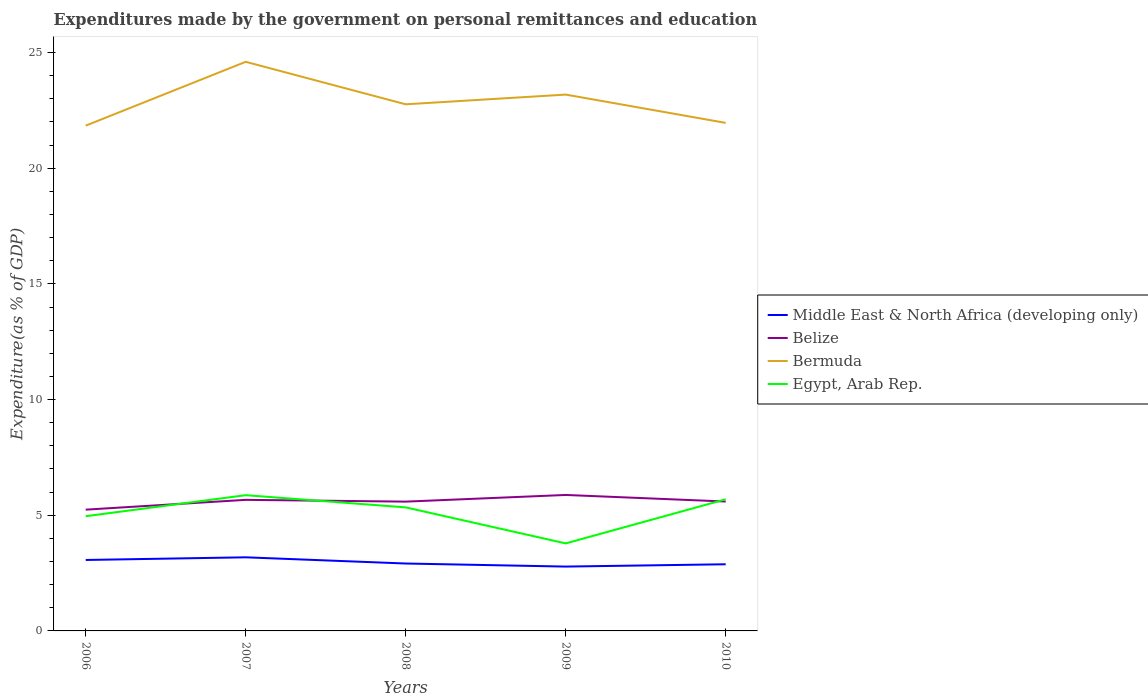Is the number of lines equal to the number of legend labels?
Make the answer very short. Yes. Across all years, what is the maximum expenditures made by the government on personal remittances and education in Bermuda?
Give a very brief answer. 21.84. What is the total expenditures made by the government on personal remittances and education in Middle East & North Africa (developing only) in the graph?
Your answer should be very brief. -0.11. What is the difference between the highest and the second highest expenditures made by the government on personal remittances and education in Egypt, Arab Rep.?
Your answer should be very brief. 2.08. Is the expenditures made by the government on personal remittances and education in Middle East & North Africa (developing only) strictly greater than the expenditures made by the government on personal remittances and education in Egypt, Arab Rep. over the years?
Keep it short and to the point. Yes. How many years are there in the graph?
Your answer should be compact. 5. What is the difference between two consecutive major ticks on the Y-axis?
Offer a terse response. 5. Does the graph contain grids?
Ensure brevity in your answer.  No. Where does the legend appear in the graph?
Your answer should be compact. Center right. How many legend labels are there?
Ensure brevity in your answer.  4. What is the title of the graph?
Your response must be concise. Expenditures made by the government on personal remittances and education. What is the label or title of the X-axis?
Your response must be concise. Years. What is the label or title of the Y-axis?
Your answer should be very brief. Expenditure(as % of GDP). What is the Expenditure(as % of GDP) in Middle East & North Africa (developing only) in 2006?
Offer a terse response. 3.07. What is the Expenditure(as % of GDP) of Belize in 2006?
Provide a succinct answer. 5.24. What is the Expenditure(as % of GDP) in Bermuda in 2006?
Give a very brief answer. 21.84. What is the Expenditure(as % of GDP) of Egypt, Arab Rep. in 2006?
Your response must be concise. 4.96. What is the Expenditure(as % of GDP) in Middle East & North Africa (developing only) in 2007?
Your response must be concise. 3.18. What is the Expenditure(as % of GDP) in Belize in 2007?
Your answer should be compact. 5.67. What is the Expenditure(as % of GDP) of Bermuda in 2007?
Make the answer very short. 24.6. What is the Expenditure(as % of GDP) of Egypt, Arab Rep. in 2007?
Provide a short and direct response. 5.87. What is the Expenditure(as % of GDP) in Middle East & North Africa (developing only) in 2008?
Give a very brief answer. 2.91. What is the Expenditure(as % of GDP) in Belize in 2008?
Provide a succinct answer. 5.59. What is the Expenditure(as % of GDP) of Bermuda in 2008?
Your response must be concise. 22.76. What is the Expenditure(as % of GDP) in Egypt, Arab Rep. in 2008?
Your response must be concise. 5.34. What is the Expenditure(as % of GDP) of Middle East & North Africa (developing only) in 2009?
Provide a short and direct response. 2.78. What is the Expenditure(as % of GDP) in Belize in 2009?
Your answer should be very brief. 5.88. What is the Expenditure(as % of GDP) of Bermuda in 2009?
Provide a succinct answer. 23.18. What is the Expenditure(as % of GDP) of Egypt, Arab Rep. in 2009?
Provide a succinct answer. 3.78. What is the Expenditure(as % of GDP) of Middle East & North Africa (developing only) in 2010?
Your answer should be very brief. 2.88. What is the Expenditure(as % of GDP) of Belize in 2010?
Provide a succinct answer. 5.59. What is the Expenditure(as % of GDP) in Bermuda in 2010?
Your answer should be compact. 21.96. What is the Expenditure(as % of GDP) of Egypt, Arab Rep. in 2010?
Offer a very short reply. 5.69. Across all years, what is the maximum Expenditure(as % of GDP) of Middle East & North Africa (developing only)?
Give a very brief answer. 3.18. Across all years, what is the maximum Expenditure(as % of GDP) of Belize?
Give a very brief answer. 5.88. Across all years, what is the maximum Expenditure(as % of GDP) of Bermuda?
Your answer should be very brief. 24.6. Across all years, what is the maximum Expenditure(as % of GDP) in Egypt, Arab Rep.?
Your answer should be compact. 5.87. Across all years, what is the minimum Expenditure(as % of GDP) in Middle East & North Africa (developing only)?
Ensure brevity in your answer.  2.78. Across all years, what is the minimum Expenditure(as % of GDP) in Belize?
Your answer should be compact. 5.24. Across all years, what is the minimum Expenditure(as % of GDP) of Bermuda?
Your response must be concise. 21.84. Across all years, what is the minimum Expenditure(as % of GDP) in Egypt, Arab Rep.?
Make the answer very short. 3.78. What is the total Expenditure(as % of GDP) in Middle East & North Africa (developing only) in the graph?
Your answer should be very brief. 14.83. What is the total Expenditure(as % of GDP) of Belize in the graph?
Make the answer very short. 27.97. What is the total Expenditure(as % of GDP) of Bermuda in the graph?
Your answer should be very brief. 114.34. What is the total Expenditure(as % of GDP) in Egypt, Arab Rep. in the graph?
Provide a succinct answer. 25.64. What is the difference between the Expenditure(as % of GDP) of Middle East & North Africa (developing only) in 2006 and that in 2007?
Provide a short and direct response. -0.11. What is the difference between the Expenditure(as % of GDP) in Belize in 2006 and that in 2007?
Your answer should be very brief. -0.42. What is the difference between the Expenditure(as % of GDP) in Bermuda in 2006 and that in 2007?
Your response must be concise. -2.76. What is the difference between the Expenditure(as % of GDP) in Egypt, Arab Rep. in 2006 and that in 2007?
Your response must be concise. -0.91. What is the difference between the Expenditure(as % of GDP) in Middle East & North Africa (developing only) in 2006 and that in 2008?
Give a very brief answer. 0.15. What is the difference between the Expenditure(as % of GDP) in Belize in 2006 and that in 2008?
Keep it short and to the point. -0.35. What is the difference between the Expenditure(as % of GDP) in Bermuda in 2006 and that in 2008?
Give a very brief answer. -0.92. What is the difference between the Expenditure(as % of GDP) of Egypt, Arab Rep. in 2006 and that in 2008?
Ensure brevity in your answer.  -0.38. What is the difference between the Expenditure(as % of GDP) of Middle East & North Africa (developing only) in 2006 and that in 2009?
Ensure brevity in your answer.  0.29. What is the difference between the Expenditure(as % of GDP) of Belize in 2006 and that in 2009?
Provide a short and direct response. -0.64. What is the difference between the Expenditure(as % of GDP) of Bermuda in 2006 and that in 2009?
Keep it short and to the point. -1.34. What is the difference between the Expenditure(as % of GDP) in Egypt, Arab Rep. in 2006 and that in 2009?
Offer a very short reply. 1.18. What is the difference between the Expenditure(as % of GDP) in Middle East & North Africa (developing only) in 2006 and that in 2010?
Provide a short and direct response. 0.19. What is the difference between the Expenditure(as % of GDP) of Belize in 2006 and that in 2010?
Your answer should be very brief. -0.35. What is the difference between the Expenditure(as % of GDP) of Bermuda in 2006 and that in 2010?
Your answer should be compact. -0.12. What is the difference between the Expenditure(as % of GDP) in Egypt, Arab Rep. in 2006 and that in 2010?
Offer a terse response. -0.73. What is the difference between the Expenditure(as % of GDP) in Middle East & North Africa (developing only) in 2007 and that in 2008?
Offer a terse response. 0.27. What is the difference between the Expenditure(as % of GDP) of Belize in 2007 and that in 2008?
Your answer should be compact. 0.08. What is the difference between the Expenditure(as % of GDP) in Bermuda in 2007 and that in 2008?
Offer a very short reply. 1.84. What is the difference between the Expenditure(as % of GDP) in Egypt, Arab Rep. in 2007 and that in 2008?
Your answer should be very brief. 0.53. What is the difference between the Expenditure(as % of GDP) in Middle East & North Africa (developing only) in 2007 and that in 2009?
Your answer should be compact. 0.4. What is the difference between the Expenditure(as % of GDP) of Belize in 2007 and that in 2009?
Keep it short and to the point. -0.21. What is the difference between the Expenditure(as % of GDP) in Bermuda in 2007 and that in 2009?
Provide a short and direct response. 1.42. What is the difference between the Expenditure(as % of GDP) of Egypt, Arab Rep. in 2007 and that in 2009?
Keep it short and to the point. 2.08. What is the difference between the Expenditure(as % of GDP) of Middle East & North Africa (developing only) in 2007 and that in 2010?
Give a very brief answer. 0.3. What is the difference between the Expenditure(as % of GDP) of Belize in 2007 and that in 2010?
Provide a short and direct response. 0.07. What is the difference between the Expenditure(as % of GDP) in Bermuda in 2007 and that in 2010?
Provide a short and direct response. 2.64. What is the difference between the Expenditure(as % of GDP) in Egypt, Arab Rep. in 2007 and that in 2010?
Make the answer very short. 0.18. What is the difference between the Expenditure(as % of GDP) in Middle East & North Africa (developing only) in 2008 and that in 2009?
Provide a succinct answer. 0.13. What is the difference between the Expenditure(as % of GDP) of Belize in 2008 and that in 2009?
Make the answer very short. -0.29. What is the difference between the Expenditure(as % of GDP) of Bermuda in 2008 and that in 2009?
Your answer should be compact. -0.42. What is the difference between the Expenditure(as % of GDP) of Egypt, Arab Rep. in 2008 and that in 2009?
Keep it short and to the point. 1.56. What is the difference between the Expenditure(as % of GDP) in Middle East & North Africa (developing only) in 2008 and that in 2010?
Keep it short and to the point. 0.03. What is the difference between the Expenditure(as % of GDP) of Belize in 2008 and that in 2010?
Provide a short and direct response. -0. What is the difference between the Expenditure(as % of GDP) in Bermuda in 2008 and that in 2010?
Your answer should be very brief. 0.8. What is the difference between the Expenditure(as % of GDP) of Egypt, Arab Rep. in 2008 and that in 2010?
Offer a very short reply. -0.35. What is the difference between the Expenditure(as % of GDP) in Middle East & North Africa (developing only) in 2009 and that in 2010?
Your answer should be compact. -0.1. What is the difference between the Expenditure(as % of GDP) of Belize in 2009 and that in 2010?
Keep it short and to the point. 0.28. What is the difference between the Expenditure(as % of GDP) of Bermuda in 2009 and that in 2010?
Your response must be concise. 1.22. What is the difference between the Expenditure(as % of GDP) in Egypt, Arab Rep. in 2009 and that in 2010?
Provide a succinct answer. -1.91. What is the difference between the Expenditure(as % of GDP) of Middle East & North Africa (developing only) in 2006 and the Expenditure(as % of GDP) of Belize in 2007?
Give a very brief answer. -2.6. What is the difference between the Expenditure(as % of GDP) in Middle East & North Africa (developing only) in 2006 and the Expenditure(as % of GDP) in Bermuda in 2007?
Provide a succinct answer. -21.53. What is the difference between the Expenditure(as % of GDP) in Middle East & North Africa (developing only) in 2006 and the Expenditure(as % of GDP) in Egypt, Arab Rep. in 2007?
Offer a very short reply. -2.8. What is the difference between the Expenditure(as % of GDP) of Belize in 2006 and the Expenditure(as % of GDP) of Bermuda in 2007?
Give a very brief answer. -19.36. What is the difference between the Expenditure(as % of GDP) in Belize in 2006 and the Expenditure(as % of GDP) in Egypt, Arab Rep. in 2007?
Offer a very short reply. -0.63. What is the difference between the Expenditure(as % of GDP) in Bermuda in 2006 and the Expenditure(as % of GDP) in Egypt, Arab Rep. in 2007?
Your answer should be very brief. 15.97. What is the difference between the Expenditure(as % of GDP) of Middle East & North Africa (developing only) in 2006 and the Expenditure(as % of GDP) of Belize in 2008?
Your answer should be very brief. -2.52. What is the difference between the Expenditure(as % of GDP) in Middle East & North Africa (developing only) in 2006 and the Expenditure(as % of GDP) in Bermuda in 2008?
Your answer should be compact. -19.7. What is the difference between the Expenditure(as % of GDP) in Middle East & North Africa (developing only) in 2006 and the Expenditure(as % of GDP) in Egypt, Arab Rep. in 2008?
Your response must be concise. -2.27. What is the difference between the Expenditure(as % of GDP) of Belize in 2006 and the Expenditure(as % of GDP) of Bermuda in 2008?
Ensure brevity in your answer.  -17.52. What is the difference between the Expenditure(as % of GDP) in Belize in 2006 and the Expenditure(as % of GDP) in Egypt, Arab Rep. in 2008?
Offer a terse response. -0.1. What is the difference between the Expenditure(as % of GDP) in Bermuda in 2006 and the Expenditure(as % of GDP) in Egypt, Arab Rep. in 2008?
Provide a short and direct response. 16.5. What is the difference between the Expenditure(as % of GDP) of Middle East & North Africa (developing only) in 2006 and the Expenditure(as % of GDP) of Belize in 2009?
Your response must be concise. -2.81. What is the difference between the Expenditure(as % of GDP) of Middle East & North Africa (developing only) in 2006 and the Expenditure(as % of GDP) of Bermuda in 2009?
Provide a short and direct response. -20.12. What is the difference between the Expenditure(as % of GDP) in Middle East & North Africa (developing only) in 2006 and the Expenditure(as % of GDP) in Egypt, Arab Rep. in 2009?
Your response must be concise. -0.72. What is the difference between the Expenditure(as % of GDP) in Belize in 2006 and the Expenditure(as % of GDP) in Bermuda in 2009?
Ensure brevity in your answer.  -17.94. What is the difference between the Expenditure(as % of GDP) in Belize in 2006 and the Expenditure(as % of GDP) in Egypt, Arab Rep. in 2009?
Your answer should be very brief. 1.46. What is the difference between the Expenditure(as % of GDP) in Bermuda in 2006 and the Expenditure(as % of GDP) in Egypt, Arab Rep. in 2009?
Make the answer very short. 18.06. What is the difference between the Expenditure(as % of GDP) in Middle East & North Africa (developing only) in 2006 and the Expenditure(as % of GDP) in Belize in 2010?
Give a very brief answer. -2.53. What is the difference between the Expenditure(as % of GDP) of Middle East & North Africa (developing only) in 2006 and the Expenditure(as % of GDP) of Bermuda in 2010?
Offer a terse response. -18.89. What is the difference between the Expenditure(as % of GDP) of Middle East & North Africa (developing only) in 2006 and the Expenditure(as % of GDP) of Egypt, Arab Rep. in 2010?
Offer a terse response. -2.62. What is the difference between the Expenditure(as % of GDP) in Belize in 2006 and the Expenditure(as % of GDP) in Bermuda in 2010?
Give a very brief answer. -16.72. What is the difference between the Expenditure(as % of GDP) in Belize in 2006 and the Expenditure(as % of GDP) in Egypt, Arab Rep. in 2010?
Keep it short and to the point. -0.45. What is the difference between the Expenditure(as % of GDP) of Bermuda in 2006 and the Expenditure(as % of GDP) of Egypt, Arab Rep. in 2010?
Offer a very short reply. 16.15. What is the difference between the Expenditure(as % of GDP) of Middle East & North Africa (developing only) in 2007 and the Expenditure(as % of GDP) of Belize in 2008?
Your answer should be compact. -2.41. What is the difference between the Expenditure(as % of GDP) in Middle East & North Africa (developing only) in 2007 and the Expenditure(as % of GDP) in Bermuda in 2008?
Offer a terse response. -19.58. What is the difference between the Expenditure(as % of GDP) of Middle East & North Africa (developing only) in 2007 and the Expenditure(as % of GDP) of Egypt, Arab Rep. in 2008?
Make the answer very short. -2.16. What is the difference between the Expenditure(as % of GDP) of Belize in 2007 and the Expenditure(as % of GDP) of Bermuda in 2008?
Offer a very short reply. -17.1. What is the difference between the Expenditure(as % of GDP) in Belize in 2007 and the Expenditure(as % of GDP) in Egypt, Arab Rep. in 2008?
Make the answer very short. 0.33. What is the difference between the Expenditure(as % of GDP) of Bermuda in 2007 and the Expenditure(as % of GDP) of Egypt, Arab Rep. in 2008?
Provide a succinct answer. 19.26. What is the difference between the Expenditure(as % of GDP) in Middle East & North Africa (developing only) in 2007 and the Expenditure(as % of GDP) in Belize in 2009?
Provide a succinct answer. -2.7. What is the difference between the Expenditure(as % of GDP) of Middle East & North Africa (developing only) in 2007 and the Expenditure(as % of GDP) of Bermuda in 2009?
Provide a succinct answer. -20. What is the difference between the Expenditure(as % of GDP) in Middle East & North Africa (developing only) in 2007 and the Expenditure(as % of GDP) in Egypt, Arab Rep. in 2009?
Make the answer very short. -0.6. What is the difference between the Expenditure(as % of GDP) in Belize in 2007 and the Expenditure(as % of GDP) in Bermuda in 2009?
Your response must be concise. -17.52. What is the difference between the Expenditure(as % of GDP) of Belize in 2007 and the Expenditure(as % of GDP) of Egypt, Arab Rep. in 2009?
Offer a terse response. 1.88. What is the difference between the Expenditure(as % of GDP) of Bermuda in 2007 and the Expenditure(as % of GDP) of Egypt, Arab Rep. in 2009?
Your answer should be very brief. 20.82. What is the difference between the Expenditure(as % of GDP) in Middle East & North Africa (developing only) in 2007 and the Expenditure(as % of GDP) in Belize in 2010?
Provide a short and direct response. -2.41. What is the difference between the Expenditure(as % of GDP) of Middle East & North Africa (developing only) in 2007 and the Expenditure(as % of GDP) of Bermuda in 2010?
Make the answer very short. -18.78. What is the difference between the Expenditure(as % of GDP) in Middle East & North Africa (developing only) in 2007 and the Expenditure(as % of GDP) in Egypt, Arab Rep. in 2010?
Your response must be concise. -2.51. What is the difference between the Expenditure(as % of GDP) in Belize in 2007 and the Expenditure(as % of GDP) in Bermuda in 2010?
Ensure brevity in your answer.  -16.29. What is the difference between the Expenditure(as % of GDP) of Belize in 2007 and the Expenditure(as % of GDP) of Egypt, Arab Rep. in 2010?
Your answer should be very brief. -0.02. What is the difference between the Expenditure(as % of GDP) of Bermuda in 2007 and the Expenditure(as % of GDP) of Egypt, Arab Rep. in 2010?
Offer a terse response. 18.91. What is the difference between the Expenditure(as % of GDP) in Middle East & North Africa (developing only) in 2008 and the Expenditure(as % of GDP) in Belize in 2009?
Offer a terse response. -2.96. What is the difference between the Expenditure(as % of GDP) of Middle East & North Africa (developing only) in 2008 and the Expenditure(as % of GDP) of Bermuda in 2009?
Your response must be concise. -20.27. What is the difference between the Expenditure(as % of GDP) in Middle East & North Africa (developing only) in 2008 and the Expenditure(as % of GDP) in Egypt, Arab Rep. in 2009?
Make the answer very short. -0.87. What is the difference between the Expenditure(as % of GDP) of Belize in 2008 and the Expenditure(as % of GDP) of Bermuda in 2009?
Offer a terse response. -17.59. What is the difference between the Expenditure(as % of GDP) in Belize in 2008 and the Expenditure(as % of GDP) in Egypt, Arab Rep. in 2009?
Offer a terse response. 1.81. What is the difference between the Expenditure(as % of GDP) in Bermuda in 2008 and the Expenditure(as % of GDP) in Egypt, Arab Rep. in 2009?
Offer a very short reply. 18.98. What is the difference between the Expenditure(as % of GDP) of Middle East & North Africa (developing only) in 2008 and the Expenditure(as % of GDP) of Belize in 2010?
Provide a short and direct response. -2.68. What is the difference between the Expenditure(as % of GDP) of Middle East & North Africa (developing only) in 2008 and the Expenditure(as % of GDP) of Bermuda in 2010?
Offer a very short reply. -19.05. What is the difference between the Expenditure(as % of GDP) of Middle East & North Africa (developing only) in 2008 and the Expenditure(as % of GDP) of Egypt, Arab Rep. in 2010?
Your response must be concise. -2.78. What is the difference between the Expenditure(as % of GDP) in Belize in 2008 and the Expenditure(as % of GDP) in Bermuda in 2010?
Ensure brevity in your answer.  -16.37. What is the difference between the Expenditure(as % of GDP) in Belize in 2008 and the Expenditure(as % of GDP) in Egypt, Arab Rep. in 2010?
Provide a short and direct response. -0.1. What is the difference between the Expenditure(as % of GDP) of Bermuda in 2008 and the Expenditure(as % of GDP) of Egypt, Arab Rep. in 2010?
Your answer should be compact. 17.07. What is the difference between the Expenditure(as % of GDP) in Middle East & North Africa (developing only) in 2009 and the Expenditure(as % of GDP) in Belize in 2010?
Offer a terse response. -2.81. What is the difference between the Expenditure(as % of GDP) in Middle East & North Africa (developing only) in 2009 and the Expenditure(as % of GDP) in Bermuda in 2010?
Your response must be concise. -19.18. What is the difference between the Expenditure(as % of GDP) of Middle East & North Africa (developing only) in 2009 and the Expenditure(as % of GDP) of Egypt, Arab Rep. in 2010?
Offer a terse response. -2.91. What is the difference between the Expenditure(as % of GDP) of Belize in 2009 and the Expenditure(as % of GDP) of Bermuda in 2010?
Offer a very short reply. -16.08. What is the difference between the Expenditure(as % of GDP) in Belize in 2009 and the Expenditure(as % of GDP) in Egypt, Arab Rep. in 2010?
Your answer should be very brief. 0.19. What is the difference between the Expenditure(as % of GDP) of Bermuda in 2009 and the Expenditure(as % of GDP) of Egypt, Arab Rep. in 2010?
Your answer should be compact. 17.49. What is the average Expenditure(as % of GDP) in Middle East & North Africa (developing only) per year?
Keep it short and to the point. 2.96. What is the average Expenditure(as % of GDP) in Belize per year?
Give a very brief answer. 5.59. What is the average Expenditure(as % of GDP) of Bermuda per year?
Provide a short and direct response. 22.87. What is the average Expenditure(as % of GDP) in Egypt, Arab Rep. per year?
Keep it short and to the point. 5.13. In the year 2006, what is the difference between the Expenditure(as % of GDP) of Middle East & North Africa (developing only) and Expenditure(as % of GDP) of Belize?
Your answer should be compact. -2.17. In the year 2006, what is the difference between the Expenditure(as % of GDP) in Middle East & North Africa (developing only) and Expenditure(as % of GDP) in Bermuda?
Make the answer very short. -18.77. In the year 2006, what is the difference between the Expenditure(as % of GDP) of Middle East & North Africa (developing only) and Expenditure(as % of GDP) of Egypt, Arab Rep.?
Your answer should be very brief. -1.89. In the year 2006, what is the difference between the Expenditure(as % of GDP) in Belize and Expenditure(as % of GDP) in Bermuda?
Offer a terse response. -16.6. In the year 2006, what is the difference between the Expenditure(as % of GDP) of Belize and Expenditure(as % of GDP) of Egypt, Arab Rep.?
Provide a short and direct response. 0.28. In the year 2006, what is the difference between the Expenditure(as % of GDP) in Bermuda and Expenditure(as % of GDP) in Egypt, Arab Rep.?
Offer a terse response. 16.88. In the year 2007, what is the difference between the Expenditure(as % of GDP) of Middle East & North Africa (developing only) and Expenditure(as % of GDP) of Belize?
Provide a succinct answer. -2.48. In the year 2007, what is the difference between the Expenditure(as % of GDP) in Middle East & North Africa (developing only) and Expenditure(as % of GDP) in Bermuda?
Offer a terse response. -21.42. In the year 2007, what is the difference between the Expenditure(as % of GDP) of Middle East & North Africa (developing only) and Expenditure(as % of GDP) of Egypt, Arab Rep.?
Give a very brief answer. -2.69. In the year 2007, what is the difference between the Expenditure(as % of GDP) in Belize and Expenditure(as % of GDP) in Bermuda?
Your answer should be very brief. -18.93. In the year 2007, what is the difference between the Expenditure(as % of GDP) in Belize and Expenditure(as % of GDP) in Egypt, Arab Rep.?
Make the answer very short. -0.2. In the year 2007, what is the difference between the Expenditure(as % of GDP) of Bermuda and Expenditure(as % of GDP) of Egypt, Arab Rep.?
Ensure brevity in your answer.  18.73. In the year 2008, what is the difference between the Expenditure(as % of GDP) in Middle East & North Africa (developing only) and Expenditure(as % of GDP) in Belize?
Provide a succinct answer. -2.67. In the year 2008, what is the difference between the Expenditure(as % of GDP) in Middle East & North Africa (developing only) and Expenditure(as % of GDP) in Bermuda?
Your answer should be very brief. -19.85. In the year 2008, what is the difference between the Expenditure(as % of GDP) in Middle East & North Africa (developing only) and Expenditure(as % of GDP) in Egypt, Arab Rep.?
Your answer should be very brief. -2.43. In the year 2008, what is the difference between the Expenditure(as % of GDP) in Belize and Expenditure(as % of GDP) in Bermuda?
Your answer should be very brief. -17.17. In the year 2008, what is the difference between the Expenditure(as % of GDP) in Belize and Expenditure(as % of GDP) in Egypt, Arab Rep.?
Make the answer very short. 0.25. In the year 2008, what is the difference between the Expenditure(as % of GDP) of Bermuda and Expenditure(as % of GDP) of Egypt, Arab Rep.?
Make the answer very short. 17.42. In the year 2009, what is the difference between the Expenditure(as % of GDP) of Middle East & North Africa (developing only) and Expenditure(as % of GDP) of Belize?
Keep it short and to the point. -3.1. In the year 2009, what is the difference between the Expenditure(as % of GDP) of Middle East & North Africa (developing only) and Expenditure(as % of GDP) of Bermuda?
Offer a terse response. -20.4. In the year 2009, what is the difference between the Expenditure(as % of GDP) of Middle East & North Africa (developing only) and Expenditure(as % of GDP) of Egypt, Arab Rep.?
Offer a very short reply. -1. In the year 2009, what is the difference between the Expenditure(as % of GDP) in Belize and Expenditure(as % of GDP) in Bermuda?
Ensure brevity in your answer.  -17.31. In the year 2009, what is the difference between the Expenditure(as % of GDP) in Belize and Expenditure(as % of GDP) in Egypt, Arab Rep.?
Offer a very short reply. 2.09. In the year 2009, what is the difference between the Expenditure(as % of GDP) of Bermuda and Expenditure(as % of GDP) of Egypt, Arab Rep.?
Give a very brief answer. 19.4. In the year 2010, what is the difference between the Expenditure(as % of GDP) of Middle East & North Africa (developing only) and Expenditure(as % of GDP) of Belize?
Your answer should be very brief. -2.71. In the year 2010, what is the difference between the Expenditure(as % of GDP) in Middle East & North Africa (developing only) and Expenditure(as % of GDP) in Bermuda?
Make the answer very short. -19.08. In the year 2010, what is the difference between the Expenditure(as % of GDP) of Middle East & North Africa (developing only) and Expenditure(as % of GDP) of Egypt, Arab Rep.?
Provide a succinct answer. -2.81. In the year 2010, what is the difference between the Expenditure(as % of GDP) in Belize and Expenditure(as % of GDP) in Bermuda?
Keep it short and to the point. -16.37. In the year 2010, what is the difference between the Expenditure(as % of GDP) in Belize and Expenditure(as % of GDP) in Egypt, Arab Rep.?
Your answer should be compact. -0.1. In the year 2010, what is the difference between the Expenditure(as % of GDP) in Bermuda and Expenditure(as % of GDP) in Egypt, Arab Rep.?
Your answer should be very brief. 16.27. What is the ratio of the Expenditure(as % of GDP) of Middle East & North Africa (developing only) in 2006 to that in 2007?
Provide a short and direct response. 0.96. What is the ratio of the Expenditure(as % of GDP) of Belize in 2006 to that in 2007?
Make the answer very short. 0.93. What is the ratio of the Expenditure(as % of GDP) in Bermuda in 2006 to that in 2007?
Ensure brevity in your answer.  0.89. What is the ratio of the Expenditure(as % of GDP) in Egypt, Arab Rep. in 2006 to that in 2007?
Offer a very short reply. 0.85. What is the ratio of the Expenditure(as % of GDP) of Middle East & North Africa (developing only) in 2006 to that in 2008?
Ensure brevity in your answer.  1.05. What is the ratio of the Expenditure(as % of GDP) in Belize in 2006 to that in 2008?
Your answer should be very brief. 0.94. What is the ratio of the Expenditure(as % of GDP) of Bermuda in 2006 to that in 2008?
Your response must be concise. 0.96. What is the ratio of the Expenditure(as % of GDP) of Egypt, Arab Rep. in 2006 to that in 2008?
Your answer should be compact. 0.93. What is the ratio of the Expenditure(as % of GDP) of Middle East & North Africa (developing only) in 2006 to that in 2009?
Give a very brief answer. 1.1. What is the ratio of the Expenditure(as % of GDP) of Belize in 2006 to that in 2009?
Make the answer very short. 0.89. What is the ratio of the Expenditure(as % of GDP) of Bermuda in 2006 to that in 2009?
Ensure brevity in your answer.  0.94. What is the ratio of the Expenditure(as % of GDP) in Egypt, Arab Rep. in 2006 to that in 2009?
Keep it short and to the point. 1.31. What is the ratio of the Expenditure(as % of GDP) in Middle East & North Africa (developing only) in 2006 to that in 2010?
Provide a succinct answer. 1.06. What is the ratio of the Expenditure(as % of GDP) of Belize in 2006 to that in 2010?
Offer a terse response. 0.94. What is the ratio of the Expenditure(as % of GDP) in Egypt, Arab Rep. in 2006 to that in 2010?
Your response must be concise. 0.87. What is the ratio of the Expenditure(as % of GDP) of Middle East & North Africa (developing only) in 2007 to that in 2008?
Provide a short and direct response. 1.09. What is the ratio of the Expenditure(as % of GDP) in Belize in 2007 to that in 2008?
Provide a short and direct response. 1.01. What is the ratio of the Expenditure(as % of GDP) in Bermuda in 2007 to that in 2008?
Give a very brief answer. 1.08. What is the ratio of the Expenditure(as % of GDP) of Egypt, Arab Rep. in 2007 to that in 2008?
Offer a very short reply. 1.1. What is the ratio of the Expenditure(as % of GDP) of Middle East & North Africa (developing only) in 2007 to that in 2009?
Make the answer very short. 1.14. What is the ratio of the Expenditure(as % of GDP) in Bermuda in 2007 to that in 2009?
Your answer should be compact. 1.06. What is the ratio of the Expenditure(as % of GDP) of Egypt, Arab Rep. in 2007 to that in 2009?
Your answer should be compact. 1.55. What is the ratio of the Expenditure(as % of GDP) in Middle East & North Africa (developing only) in 2007 to that in 2010?
Provide a succinct answer. 1.1. What is the ratio of the Expenditure(as % of GDP) in Belize in 2007 to that in 2010?
Your response must be concise. 1.01. What is the ratio of the Expenditure(as % of GDP) in Bermuda in 2007 to that in 2010?
Ensure brevity in your answer.  1.12. What is the ratio of the Expenditure(as % of GDP) of Egypt, Arab Rep. in 2007 to that in 2010?
Provide a succinct answer. 1.03. What is the ratio of the Expenditure(as % of GDP) in Middle East & North Africa (developing only) in 2008 to that in 2009?
Your answer should be very brief. 1.05. What is the ratio of the Expenditure(as % of GDP) in Belize in 2008 to that in 2009?
Offer a terse response. 0.95. What is the ratio of the Expenditure(as % of GDP) in Bermuda in 2008 to that in 2009?
Give a very brief answer. 0.98. What is the ratio of the Expenditure(as % of GDP) in Egypt, Arab Rep. in 2008 to that in 2009?
Your answer should be compact. 1.41. What is the ratio of the Expenditure(as % of GDP) of Middle East & North Africa (developing only) in 2008 to that in 2010?
Offer a terse response. 1.01. What is the ratio of the Expenditure(as % of GDP) of Belize in 2008 to that in 2010?
Give a very brief answer. 1. What is the ratio of the Expenditure(as % of GDP) in Bermuda in 2008 to that in 2010?
Offer a very short reply. 1.04. What is the ratio of the Expenditure(as % of GDP) in Egypt, Arab Rep. in 2008 to that in 2010?
Make the answer very short. 0.94. What is the ratio of the Expenditure(as % of GDP) in Middle East & North Africa (developing only) in 2009 to that in 2010?
Keep it short and to the point. 0.97. What is the ratio of the Expenditure(as % of GDP) in Belize in 2009 to that in 2010?
Offer a very short reply. 1.05. What is the ratio of the Expenditure(as % of GDP) in Bermuda in 2009 to that in 2010?
Offer a terse response. 1.06. What is the ratio of the Expenditure(as % of GDP) in Egypt, Arab Rep. in 2009 to that in 2010?
Your answer should be compact. 0.67. What is the difference between the highest and the second highest Expenditure(as % of GDP) in Middle East & North Africa (developing only)?
Offer a terse response. 0.11. What is the difference between the highest and the second highest Expenditure(as % of GDP) in Belize?
Provide a short and direct response. 0.21. What is the difference between the highest and the second highest Expenditure(as % of GDP) in Bermuda?
Give a very brief answer. 1.42. What is the difference between the highest and the second highest Expenditure(as % of GDP) of Egypt, Arab Rep.?
Provide a short and direct response. 0.18. What is the difference between the highest and the lowest Expenditure(as % of GDP) of Middle East & North Africa (developing only)?
Ensure brevity in your answer.  0.4. What is the difference between the highest and the lowest Expenditure(as % of GDP) in Belize?
Your answer should be compact. 0.64. What is the difference between the highest and the lowest Expenditure(as % of GDP) in Bermuda?
Make the answer very short. 2.76. What is the difference between the highest and the lowest Expenditure(as % of GDP) of Egypt, Arab Rep.?
Keep it short and to the point. 2.08. 